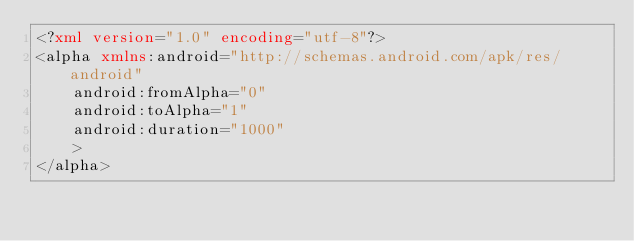<code> <loc_0><loc_0><loc_500><loc_500><_XML_><?xml version="1.0" encoding="utf-8"?>
<alpha xmlns:android="http://schemas.android.com/apk/res/android"
    android:fromAlpha="0"
    android:toAlpha="1"
    android:duration="1000"
    >
</alpha></code> 